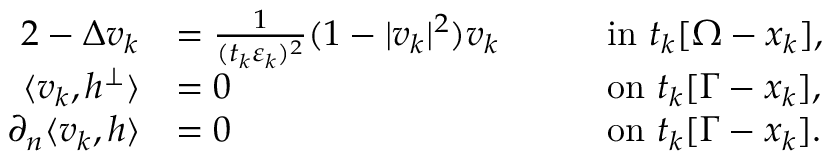<formula> <loc_0><loc_0><loc_500><loc_500>\begin{array} { r l r l } { { 2 } - \Delta v _ { k } } & { = \frac { 1 } { ( t _ { k } \varepsilon _ { k } ) ^ { 2 } } ( 1 - | v _ { k } | ^ { 2 } ) v _ { k } \quad } & & { i n \ t _ { k } [ \Omega - x _ { k } ] , } \\ { \langle v _ { k } , h ^ { \perp } \rangle } & { = 0 \quad } & & { o n \ t _ { k } [ \Gamma - x _ { k } ] , } \\ { \partial _ { n } \langle v _ { k } , h \rangle } & { = 0 \quad } & & { o n \ t _ { k } [ \Gamma - x _ { k } ] . } \end{array}</formula> 